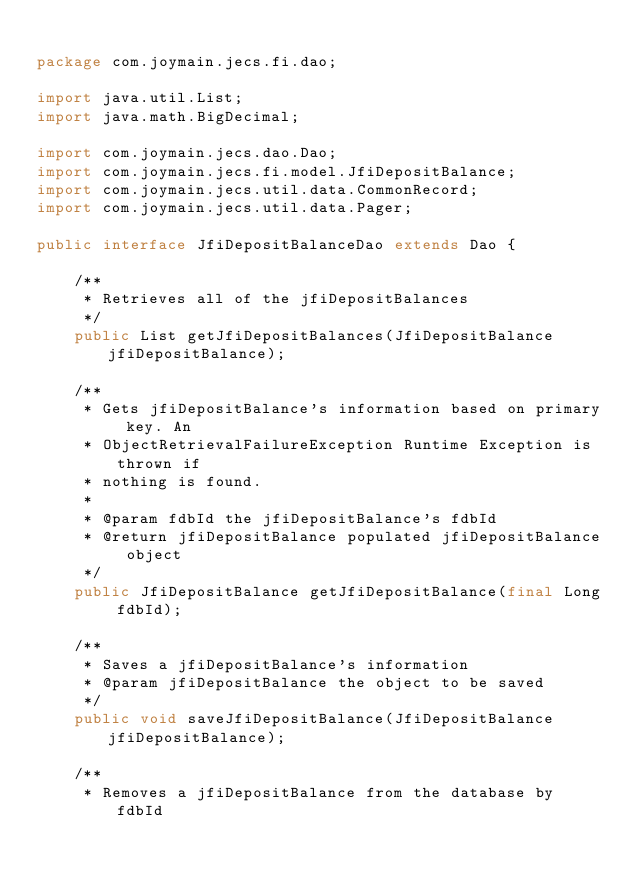Convert code to text. <code><loc_0><loc_0><loc_500><loc_500><_Java_>
package com.joymain.jecs.fi.dao;

import java.util.List;
import java.math.BigDecimal;

import com.joymain.jecs.dao.Dao;
import com.joymain.jecs.fi.model.JfiDepositBalance;
import com.joymain.jecs.util.data.CommonRecord;
import com.joymain.jecs.util.data.Pager;

public interface JfiDepositBalanceDao extends Dao {

    /**
     * Retrieves all of the jfiDepositBalances
     */
    public List getJfiDepositBalances(JfiDepositBalance jfiDepositBalance);

    /**
     * Gets jfiDepositBalance's information based on primary key. An
     * ObjectRetrievalFailureException Runtime Exception is thrown if 
     * nothing is found.
     * 
     * @param fdbId the jfiDepositBalance's fdbId
     * @return jfiDepositBalance populated jfiDepositBalance object
     */
    public JfiDepositBalance getJfiDepositBalance(final Long fdbId);

    /**
     * Saves a jfiDepositBalance's information
     * @param jfiDepositBalance the object to be saved
     */    
    public void saveJfiDepositBalance(JfiDepositBalance jfiDepositBalance);

    /**
     * Removes a jfiDepositBalance from the database by fdbId</code> 